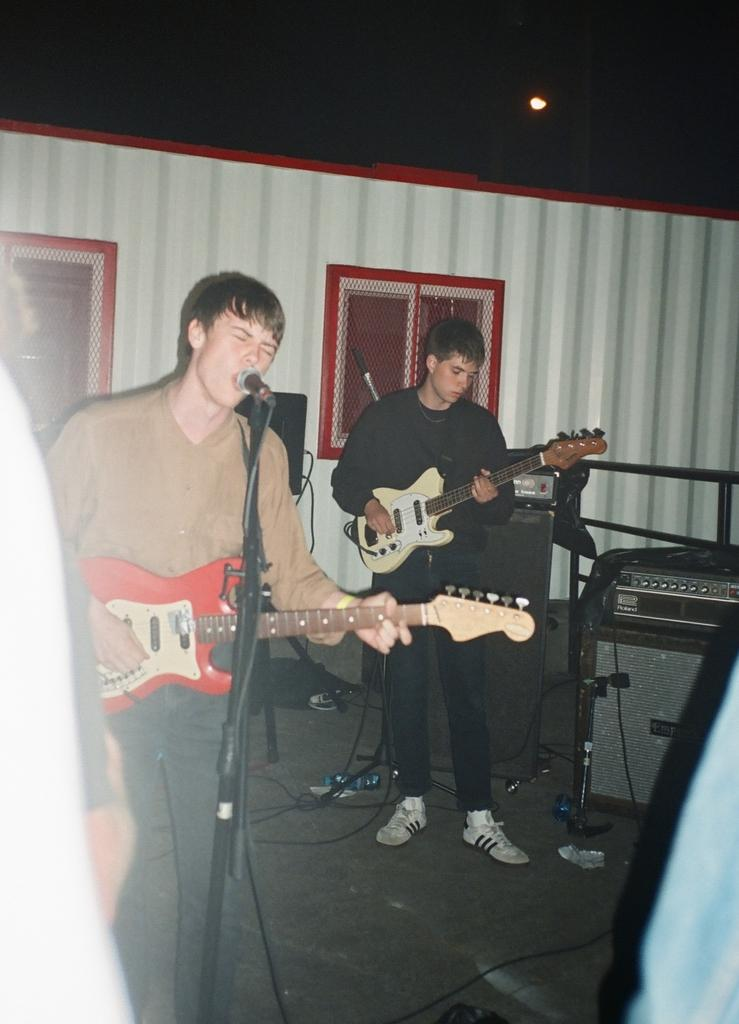How many people are in the image? There are two men in the image. What are the men doing in the image? The men are playing guitar and singing. What can be seen near the men in the image? There is a microphone in the image. What is the color of the background in the image? The background of the image is white. What type of light is visible in the image? There is a light in the image. What object is on the floor in the image? There is a bottle on the floor in the image. What type of sound can be heard coming from the popcorn in the image? There is no popcorn present in the image, so it is not possible to determine what, if any, sound might be heard. 